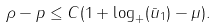<formula> <loc_0><loc_0><loc_500><loc_500>\rho - p \leq C ( 1 + \log _ { + } ( \bar { u } _ { 1 } ) - \mu ) .</formula> 